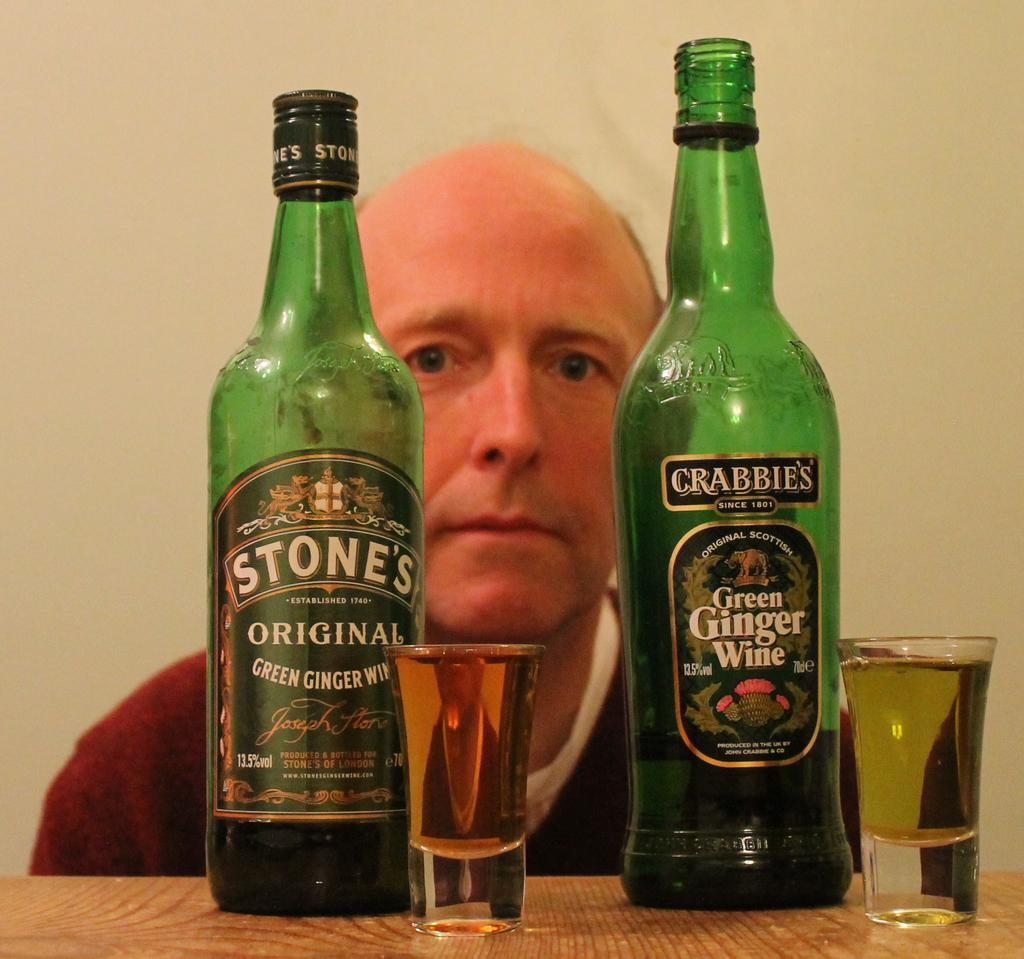<image>
Create a compact narrative representing the image presented. A man is behind two different varieties of green ginger wine. 